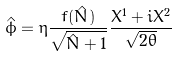Convert formula to latex. <formula><loc_0><loc_0><loc_500><loc_500>\hat { \phi } = \eta \frac { f ( \hat { N } ) } { \sqrt { \hat { N } + 1 } } \frac { X ^ { 1 } + i X ^ { 2 } } { \sqrt { 2 \theta } }</formula> 